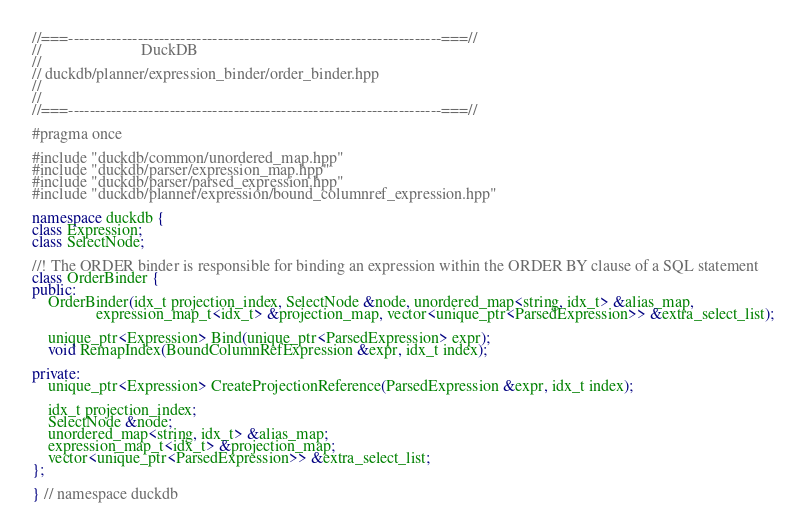<code> <loc_0><loc_0><loc_500><loc_500><_C++_>//===----------------------------------------------------------------------===//
//                         DuckDB
//
// duckdb/planner/expression_binder/order_binder.hpp
//
//
//===----------------------------------------------------------------------===//

#pragma once

#include "duckdb/common/unordered_map.hpp"
#include "duckdb/parser/expression_map.hpp"
#include "duckdb/parser/parsed_expression.hpp"
#include "duckdb/planner/expression/bound_columnref_expression.hpp"

namespace duckdb {
class Expression;
class SelectNode;

//! The ORDER binder is responsible for binding an expression within the ORDER BY clause of a SQL statement
class OrderBinder {
public:
	OrderBinder(idx_t projection_index, SelectNode &node, unordered_map<string, idx_t> &alias_map,
	            expression_map_t<idx_t> &projection_map, vector<unique_ptr<ParsedExpression>> &extra_select_list);

	unique_ptr<Expression> Bind(unique_ptr<ParsedExpression> expr);
	void RemapIndex(BoundColumnRefExpression &expr, idx_t index);

private:
	unique_ptr<Expression> CreateProjectionReference(ParsedExpression &expr, idx_t index);

	idx_t projection_index;
	SelectNode &node;
	unordered_map<string, idx_t> &alias_map;
	expression_map_t<idx_t> &projection_map;
	vector<unique_ptr<ParsedExpression>> &extra_select_list;
};

} // namespace duckdb
</code> 